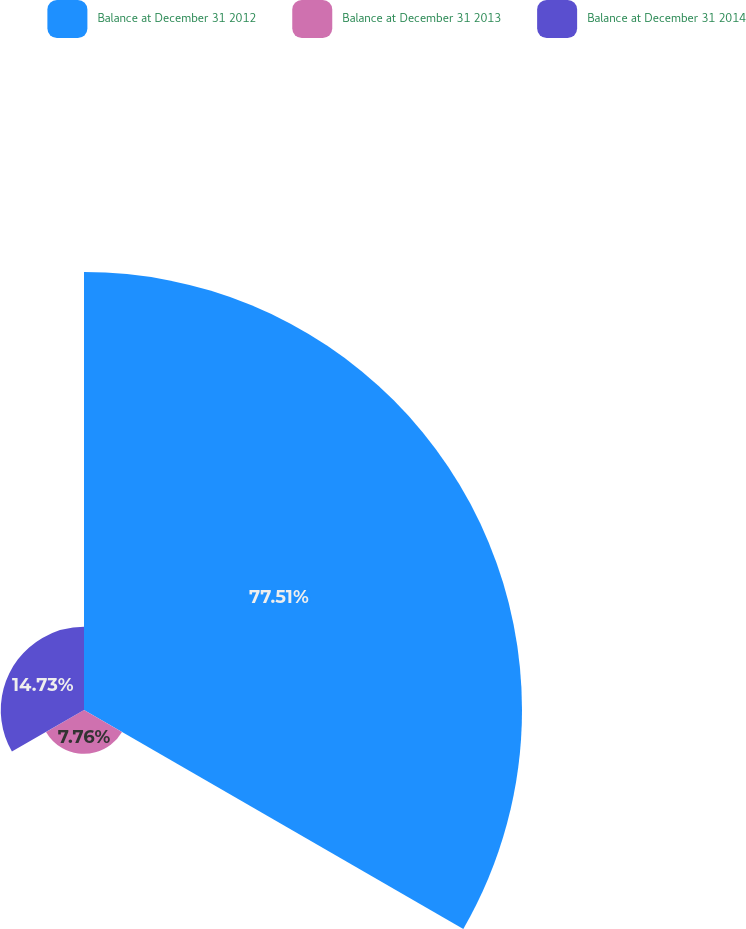Convert chart. <chart><loc_0><loc_0><loc_500><loc_500><pie_chart><fcel>Balance at December 31 2012<fcel>Balance at December 31 2013<fcel>Balance at December 31 2014<nl><fcel>77.51%<fcel>7.76%<fcel>14.73%<nl></chart> 